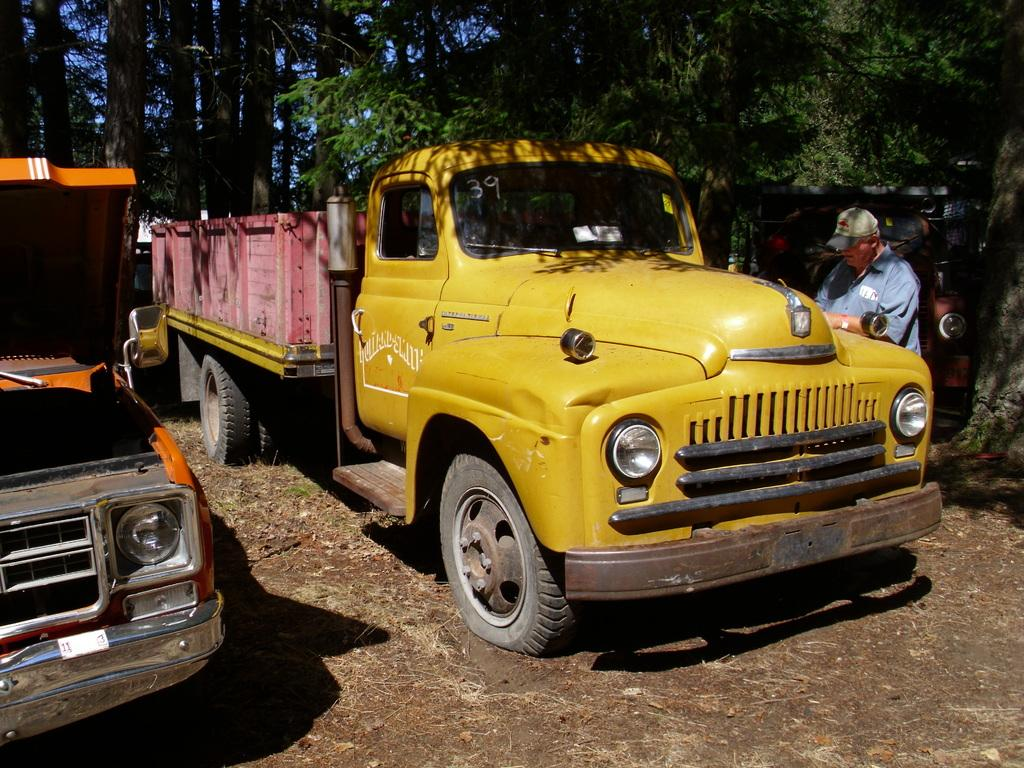What can be seen on the ground in the image? There are vehicles on the ground in the image. Can you describe the person's location in relation to the truck? A person is near a truck on the right side of the image. What type of natural elements can be seen at the top of the image? Trees are visible at the top of the image. What type of suit is the person wearing while sleeping in the image? There is no person sleeping or wearing a suit in the image. What boundary is visible between the vehicles and the trees in the image? There is no boundary visible between the vehicles and the trees in the image. 